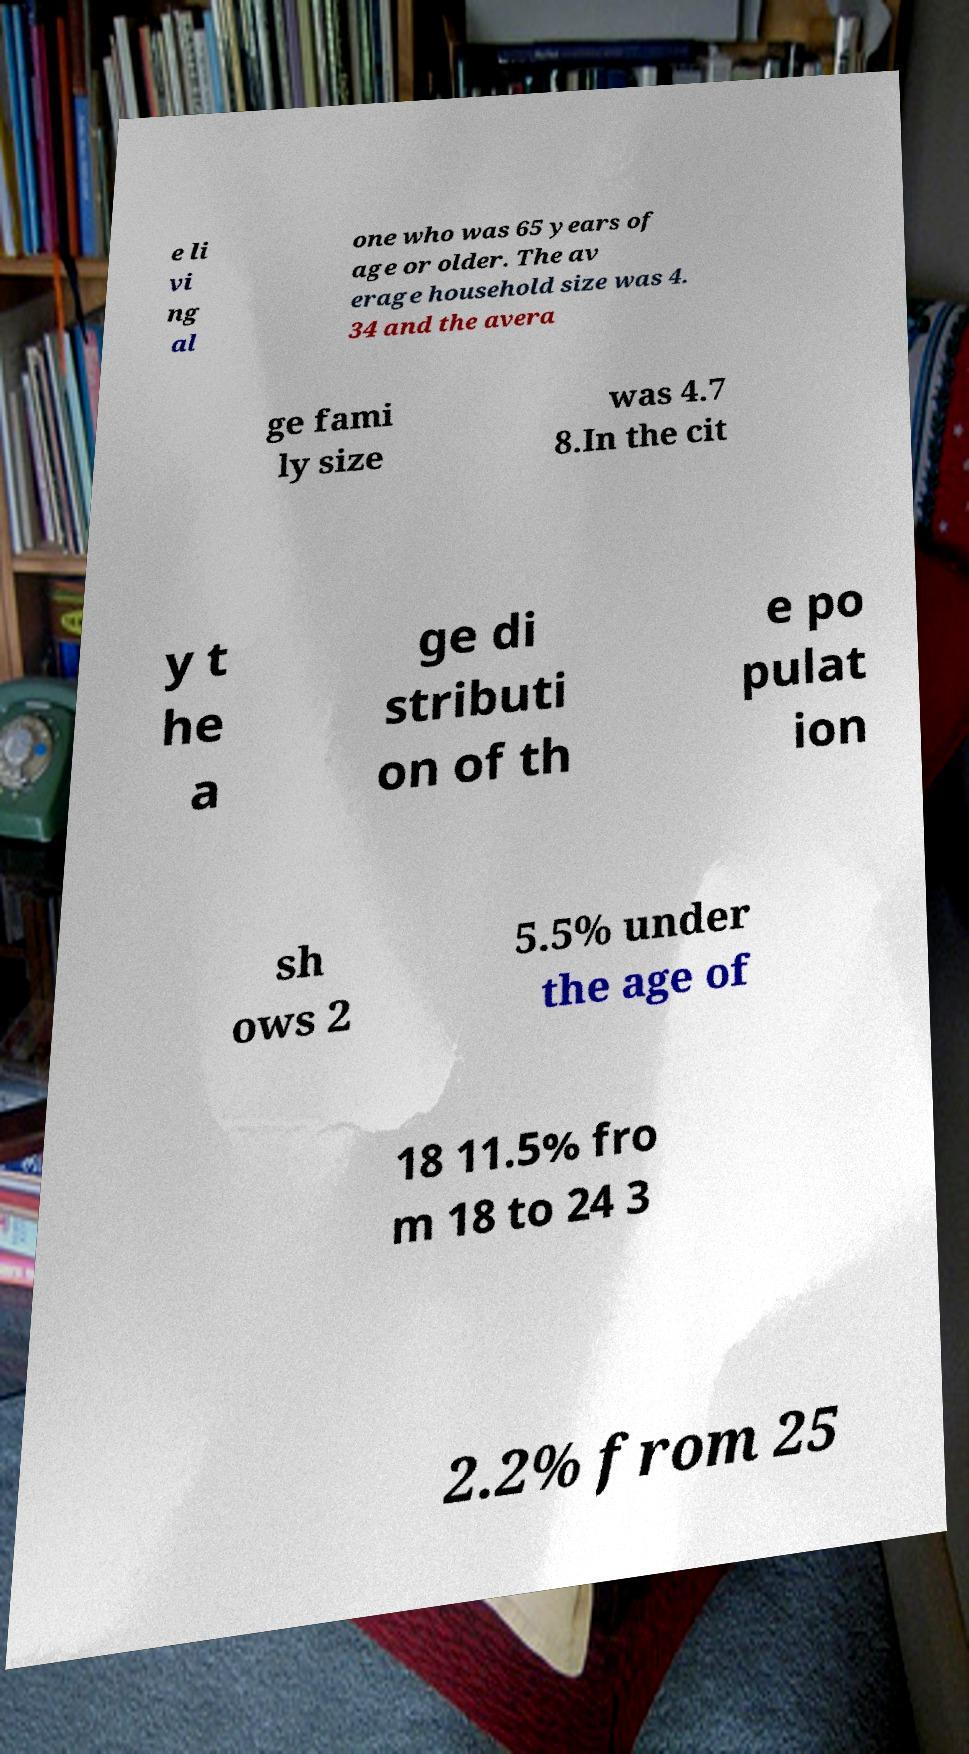Could you assist in decoding the text presented in this image and type it out clearly? e li vi ng al one who was 65 years of age or older. The av erage household size was 4. 34 and the avera ge fami ly size was 4.7 8.In the cit y t he a ge di stributi on of th e po pulat ion sh ows 2 5.5% under the age of 18 11.5% fro m 18 to 24 3 2.2% from 25 